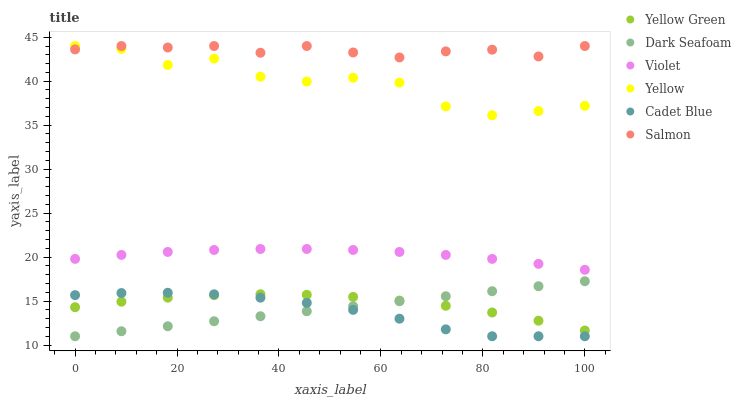Does Cadet Blue have the minimum area under the curve?
Answer yes or no. Yes. Does Salmon have the maximum area under the curve?
Answer yes or no. Yes. Does Yellow Green have the minimum area under the curve?
Answer yes or no. No. Does Yellow Green have the maximum area under the curve?
Answer yes or no. No. Is Dark Seafoam the smoothest?
Answer yes or no. Yes. Is Yellow the roughest?
Answer yes or no. Yes. Is Yellow Green the smoothest?
Answer yes or no. No. Is Yellow Green the roughest?
Answer yes or no. No. Does Cadet Blue have the lowest value?
Answer yes or no. Yes. Does Yellow Green have the lowest value?
Answer yes or no. No. Does Yellow have the highest value?
Answer yes or no. Yes. Does Yellow Green have the highest value?
Answer yes or no. No. Is Cadet Blue less than Salmon?
Answer yes or no. Yes. Is Yellow greater than Violet?
Answer yes or no. Yes. Does Yellow intersect Salmon?
Answer yes or no. Yes. Is Yellow less than Salmon?
Answer yes or no. No. Is Yellow greater than Salmon?
Answer yes or no. No. Does Cadet Blue intersect Salmon?
Answer yes or no. No. 